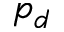Convert formula to latex. <formula><loc_0><loc_0><loc_500><loc_500>p _ { d }</formula> 